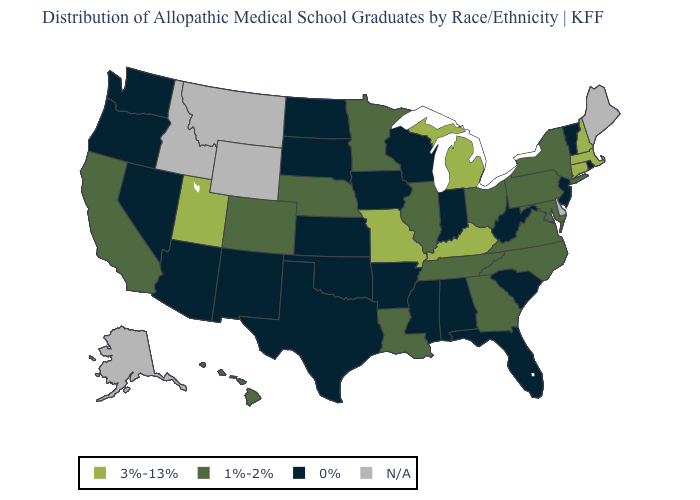What is the highest value in the USA?
Keep it brief. 3%-13%. Among the states that border Montana , which have the highest value?
Give a very brief answer. North Dakota, South Dakota. Which states have the lowest value in the USA?
Answer briefly. Alabama, Arizona, Arkansas, Florida, Indiana, Iowa, Kansas, Mississippi, Nevada, New Jersey, New Mexico, North Dakota, Oklahoma, Oregon, Rhode Island, South Carolina, South Dakota, Texas, Vermont, Washington, West Virginia, Wisconsin. What is the value of Wisconsin?
Be succinct. 0%. What is the value of Louisiana?
Concise answer only. 1%-2%. Among the states that border Mississippi , which have the lowest value?
Answer briefly. Alabama, Arkansas. What is the lowest value in the West?
Give a very brief answer. 0%. Does Nevada have the lowest value in the West?
Quick response, please. Yes. How many symbols are there in the legend?
Quick response, please. 4. Which states have the lowest value in the Northeast?
Be succinct. New Jersey, Rhode Island, Vermont. What is the value of Missouri?
Be succinct. 3%-13%. What is the value of Michigan?
Keep it brief. 3%-13%. Name the states that have a value in the range N/A?
Write a very short answer. Alaska, Delaware, Idaho, Maine, Montana, Wyoming. 